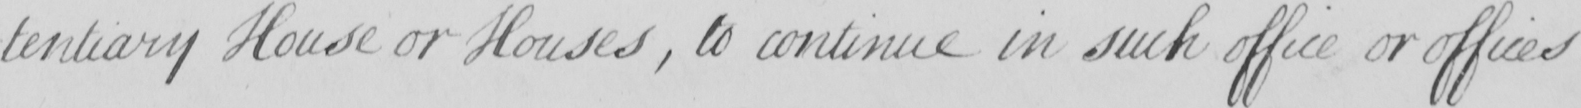What does this handwritten line say? -tentiary House or Houses , to continue in such office or offices 